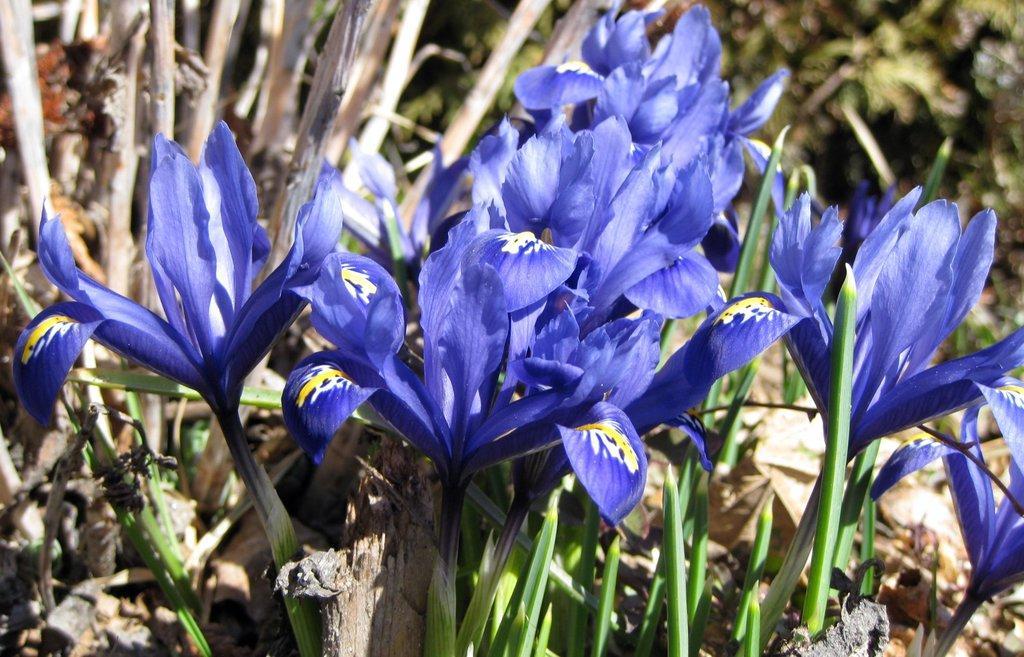How would you summarize this image in a sentence or two? In this image in the front there are flowers. In the background there is greenery. 